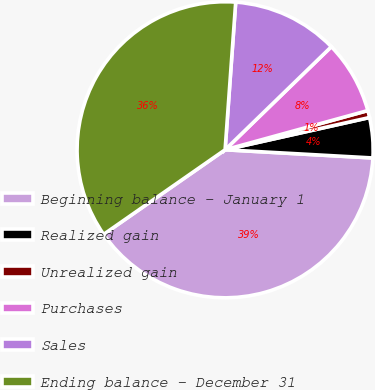Convert chart. <chart><loc_0><loc_0><loc_500><loc_500><pie_chart><fcel>Beginning balance - January 1<fcel>Realized gain<fcel>Unrealized gain<fcel>Purchases<fcel>Sales<fcel>Ending balance - December 31<nl><fcel>39.43%<fcel>4.38%<fcel>0.77%<fcel>7.99%<fcel>11.6%<fcel>35.82%<nl></chart> 